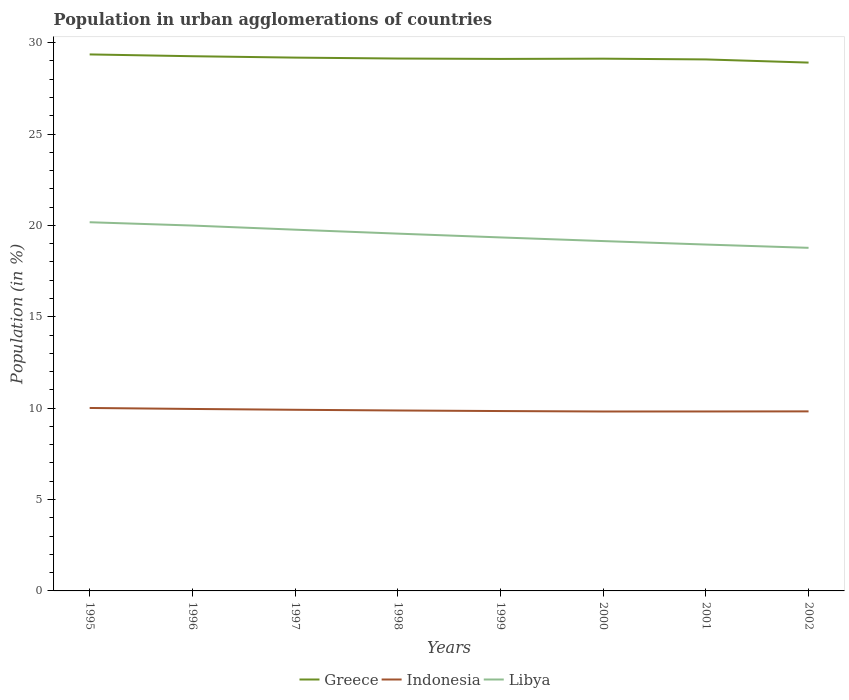How many different coloured lines are there?
Give a very brief answer. 3. Does the line corresponding to Greece intersect with the line corresponding to Indonesia?
Give a very brief answer. No. Is the number of lines equal to the number of legend labels?
Give a very brief answer. Yes. Across all years, what is the maximum percentage of population in urban agglomerations in Greece?
Your response must be concise. 28.91. In which year was the percentage of population in urban agglomerations in Indonesia maximum?
Provide a short and direct response. 2000. What is the total percentage of population in urban agglomerations in Indonesia in the graph?
Provide a succinct answer. 0.04. What is the difference between the highest and the second highest percentage of population in urban agglomerations in Indonesia?
Keep it short and to the point. 0.19. What is the difference between the highest and the lowest percentage of population in urban agglomerations in Indonesia?
Make the answer very short. 3. Is the percentage of population in urban agglomerations in Greece strictly greater than the percentage of population in urban agglomerations in Libya over the years?
Your answer should be compact. No. How many years are there in the graph?
Provide a short and direct response. 8. What is the difference between two consecutive major ticks on the Y-axis?
Give a very brief answer. 5. Are the values on the major ticks of Y-axis written in scientific E-notation?
Provide a short and direct response. No. What is the title of the graph?
Offer a terse response. Population in urban agglomerations of countries. What is the Population (in %) of Greece in 1995?
Provide a succinct answer. 29.35. What is the Population (in %) of Indonesia in 1995?
Ensure brevity in your answer.  10.01. What is the Population (in %) in Libya in 1995?
Make the answer very short. 20.17. What is the Population (in %) in Greece in 1996?
Provide a succinct answer. 29.26. What is the Population (in %) of Indonesia in 1996?
Offer a very short reply. 9.96. What is the Population (in %) in Libya in 1996?
Your answer should be very brief. 19.99. What is the Population (in %) of Greece in 1997?
Provide a short and direct response. 29.18. What is the Population (in %) in Indonesia in 1997?
Offer a terse response. 9.91. What is the Population (in %) of Libya in 1997?
Offer a very short reply. 19.77. What is the Population (in %) of Greece in 1998?
Offer a terse response. 29.13. What is the Population (in %) of Indonesia in 1998?
Offer a terse response. 9.87. What is the Population (in %) of Libya in 1998?
Keep it short and to the point. 19.55. What is the Population (in %) in Greece in 1999?
Ensure brevity in your answer.  29.11. What is the Population (in %) of Indonesia in 1999?
Your response must be concise. 9.84. What is the Population (in %) in Libya in 1999?
Keep it short and to the point. 19.34. What is the Population (in %) of Greece in 2000?
Provide a succinct answer. 29.12. What is the Population (in %) of Indonesia in 2000?
Your answer should be compact. 9.82. What is the Population (in %) of Libya in 2000?
Provide a succinct answer. 19.14. What is the Population (in %) of Greece in 2001?
Provide a succinct answer. 29.08. What is the Population (in %) of Indonesia in 2001?
Your response must be concise. 9.82. What is the Population (in %) in Libya in 2001?
Offer a very short reply. 18.95. What is the Population (in %) of Greece in 2002?
Keep it short and to the point. 28.91. What is the Population (in %) of Indonesia in 2002?
Ensure brevity in your answer.  9.82. What is the Population (in %) of Libya in 2002?
Your answer should be compact. 18.77. Across all years, what is the maximum Population (in %) of Greece?
Provide a short and direct response. 29.35. Across all years, what is the maximum Population (in %) in Indonesia?
Give a very brief answer. 10.01. Across all years, what is the maximum Population (in %) of Libya?
Keep it short and to the point. 20.17. Across all years, what is the minimum Population (in %) of Greece?
Keep it short and to the point. 28.91. Across all years, what is the minimum Population (in %) in Indonesia?
Keep it short and to the point. 9.82. Across all years, what is the minimum Population (in %) of Libya?
Offer a terse response. 18.77. What is the total Population (in %) in Greece in the graph?
Offer a terse response. 233.14. What is the total Population (in %) of Indonesia in the graph?
Make the answer very short. 79.05. What is the total Population (in %) in Libya in the graph?
Your response must be concise. 155.69. What is the difference between the Population (in %) of Greece in 1995 and that in 1996?
Give a very brief answer. 0.1. What is the difference between the Population (in %) of Indonesia in 1995 and that in 1996?
Your answer should be very brief. 0.05. What is the difference between the Population (in %) of Libya in 1995 and that in 1996?
Offer a terse response. 0.18. What is the difference between the Population (in %) in Greece in 1995 and that in 1997?
Offer a very short reply. 0.17. What is the difference between the Population (in %) in Indonesia in 1995 and that in 1997?
Ensure brevity in your answer.  0.1. What is the difference between the Population (in %) of Libya in 1995 and that in 1997?
Make the answer very short. 0.41. What is the difference between the Population (in %) in Greece in 1995 and that in 1998?
Provide a short and direct response. 0.22. What is the difference between the Population (in %) of Indonesia in 1995 and that in 1998?
Offer a terse response. 0.14. What is the difference between the Population (in %) of Libya in 1995 and that in 1998?
Offer a very short reply. 0.62. What is the difference between the Population (in %) in Greece in 1995 and that in 1999?
Give a very brief answer. 0.25. What is the difference between the Population (in %) of Indonesia in 1995 and that in 1999?
Keep it short and to the point. 0.17. What is the difference between the Population (in %) of Libya in 1995 and that in 1999?
Offer a terse response. 0.83. What is the difference between the Population (in %) in Greece in 1995 and that in 2000?
Provide a short and direct response. 0.23. What is the difference between the Population (in %) of Indonesia in 1995 and that in 2000?
Your response must be concise. 0.19. What is the difference between the Population (in %) in Libya in 1995 and that in 2000?
Provide a short and direct response. 1.03. What is the difference between the Population (in %) of Greece in 1995 and that in 2001?
Offer a terse response. 0.27. What is the difference between the Population (in %) of Indonesia in 1995 and that in 2001?
Make the answer very short. 0.19. What is the difference between the Population (in %) of Libya in 1995 and that in 2001?
Provide a short and direct response. 1.22. What is the difference between the Population (in %) of Greece in 1995 and that in 2002?
Ensure brevity in your answer.  0.45. What is the difference between the Population (in %) of Indonesia in 1995 and that in 2002?
Provide a short and direct response. 0.19. What is the difference between the Population (in %) of Libya in 1995 and that in 2002?
Your response must be concise. 1.4. What is the difference between the Population (in %) in Greece in 1996 and that in 1997?
Keep it short and to the point. 0.08. What is the difference between the Population (in %) of Indonesia in 1996 and that in 1997?
Provide a short and direct response. 0.05. What is the difference between the Population (in %) in Libya in 1996 and that in 1997?
Your answer should be very brief. 0.23. What is the difference between the Population (in %) of Greece in 1996 and that in 1998?
Ensure brevity in your answer.  0.13. What is the difference between the Population (in %) in Indonesia in 1996 and that in 1998?
Give a very brief answer. 0.08. What is the difference between the Population (in %) in Libya in 1996 and that in 1998?
Ensure brevity in your answer.  0.44. What is the difference between the Population (in %) of Greece in 1996 and that in 1999?
Offer a very short reply. 0.15. What is the difference between the Population (in %) in Indonesia in 1996 and that in 1999?
Give a very brief answer. 0.12. What is the difference between the Population (in %) in Libya in 1996 and that in 1999?
Offer a terse response. 0.65. What is the difference between the Population (in %) in Greece in 1996 and that in 2000?
Keep it short and to the point. 0.13. What is the difference between the Population (in %) of Indonesia in 1996 and that in 2000?
Ensure brevity in your answer.  0.14. What is the difference between the Population (in %) of Libya in 1996 and that in 2000?
Your response must be concise. 0.85. What is the difference between the Population (in %) in Greece in 1996 and that in 2001?
Provide a succinct answer. 0.18. What is the difference between the Population (in %) in Indonesia in 1996 and that in 2001?
Your response must be concise. 0.14. What is the difference between the Population (in %) of Libya in 1996 and that in 2001?
Your response must be concise. 1.04. What is the difference between the Population (in %) of Greece in 1996 and that in 2002?
Make the answer very short. 0.35. What is the difference between the Population (in %) of Indonesia in 1996 and that in 2002?
Provide a short and direct response. 0.13. What is the difference between the Population (in %) in Libya in 1996 and that in 2002?
Ensure brevity in your answer.  1.22. What is the difference between the Population (in %) in Greece in 1997 and that in 1998?
Give a very brief answer. 0.05. What is the difference between the Population (in %) of Indonesia in 1997 and that in 1998?
Your answer should be compact. 0.04. What is the difference between the Population (in %) of Libya in 1997 and that in 1998?
Give a very brief answer. 0.22. What is the difference between the Population (in %) in Greece in 1997 and that in 1999?
Keep it short and to the point. 0.07. What is the difference between the Population (in %) of Indonesia in 1997 and that in 1999?
Make the answer very short. 0.07. What is the difference between the Population (in %) in Libya in 1997 and that in 1999?
Provide a short and direct response. 0.42. What is the difference between the Population (in %) of Greece in 1997 and that in 2000?
Ensure brevity in your answer.  0.06. What is the difference between the Population (in %) in Indonesia in 1997 and that in 2000?
Make the answer very short. 0.09. What is the difference between the Population (in %) in Libya in 1997 and that in 2000?
Make the answer very short. 0.62. What is the difference between the Population (in %) of Greece in 1997 and that in 2001?
Offer a terse response. 0.1. What is the difference between the Population (in %) of Indonesia in 1997 and that in 2001?
Make the answer very short. 0.09. What is the difference between the Population (in %) of Libya in 1997 and that in 2001?
Your answer should be very brief. 0.81. What is the difference between the Population (in %) in Greece in 1997 and that in 2002?
Your response must be concise. 0.27. What is the difference between the Population (in %) of Indonesia in 1997 and that in 2002?
Your answer should be very brief. 0.09. What is the difference between the Population (in %) in Libya in 1997 and that in 2002?
Give a very brief answer. 0.99. What is the difference between the Population (in %) of Greece in 1998 and that in 1999?
Your response must be concise. 0.02. What is the difference between the Population (in %) of Indonesia in 1998 and that in 1999?
Give a very brief answer. 0.03. What is the difference between the Population (in %) of Libya in 1998 and that in 1999?
Your answer should be very brief. 0.21. What is the difference between the Population (in %) in Greece in 1998 and that in 2000?
Provide a short and direct response. 0.01. What is the difference between the Population (in %) of Indonesia in 1998 and that in 2000?
Your response must be concise. 0.06. What is the difference between the Population (in %) of Libya in 1998 and that in 2000?
Offer a terse response. 0.41. What is the difference between the Population (in %) of Greece in 1998 and that in 2001?
Provide a short and direct response. 0.05. What is the difference between the Population (in %) in Indonesia in 1998 and that in 2001?
Offer a terse response. 0.05. What is the difference between the Population (in %) in Libya in 1998 and that in 2001?
Provide a succinct answer. 0.6. What is the difference between the Population (in %) of Greece in 1998 and that in 2002?
Your response must be concise. 0.22. What is the difference between the Population (in %) of Indonesia in 1998 and that in 2002?
Give a very brief answer. 0.05. What is the difference between the Population (in %) of Libya in 1998 and that in 2002?
Provide a short and direct response. 0.78. What is the difference between the Population (in %) of Greece in 1999 and that in 2000?
Your response must be concise. -0.01. What is the difference between the Population (in %) in Indonesia in 1999 and that in 2000?
Offer a very short reply. 0.02. What is the difference between the Population (in %) of Libya in 1999 and that in 2000?
Offer a terse response. 0.2. What is the difference between the Population (in %) in Greece in 1999 and that in 2001?
Your answer should be compact. 0.03. What is the difference between the Population (in %) of Indonesia in 1999 and that in 2001?
Your response must be concise. 0.02. What is the difference between the Population (in %) of Libya in 1999 and that in 2001?
Offer a terse response. 0.39. What is the difference between the Population (in %) in Greece in 1999 and that in 2002?
Your answer should be very brief. 0.2. What is the difference between the Population (in %) in Indonesia in 1999 and that in 2002?
Provide a succinct answer. 0.02. What is the difference between the Population (in %) of Libya in 1999 and that in 2002?
Your answer should be compact. 0.57. What is the difference between the Population (in %) of Greece in 2000 and that in 2001?
Ensure brevity in your answer.  0.04. What is the difference between the Population (in %) of Indonesia in 2000 and that in 2001?
Keep it short and to the point. -0. What is the difference between the Population (in %) in Libya in 2000 and that in 2001?
Offer a very short reply. 0.19. What is the difference between the Population (in %) in Greece in 2000 and that in 2002?
Provide a succinct answer. 0.21. What is the difference between the Population (in %) in Indonesia in 2000 and that in 2002?
Offer a very short reply. -0.01. What is the difference between the Population (in %) of Libya in 2000 and that in 2002?
Your answer should be very brief. 0.37. What is the difference between the Population (in %) in Greece in 2001 and that in 2002?
Offer a terse response. 0.17. What is the difference between the Population (in %) in Indonesia in 2001 and that in 2002?
Offer a very short reply. -0. What is the difference between the Population (in %) of Libya in 2001 and that in 2002?
Offer a very short reply. 0.18. What is the difference between the Population (in %) in Greece in 1995 and the Population (in %) in Indonesia in 1996?
Provide a short and direct response. 19.4. What is the difference between the Population (in %) in Greece in 1995 and the Population (in %) in Libya in 1996?
Provide a short and direct response. 9.36. What is the difference between the Population (in %) of Indonesia in 1995 and the Population (in %) of Libya in 1996?
Your response must be concise. -9.98. What is the difference between the Population (in %) in Greece in 1995 and the Population (in %) in Indonesia in 1997?
Your response must be concise. 19.44. What is the difference between the Population (in %) in Greece in 1995 and the Population (in %) in Libya in 1997?
Keep it short and to the point. 9.59. What is the difference between the Population (in %) of Indonesia in 1995 and the Population (in %) of Libya in 1997?
Your response must be concise. -9.76. What is the difference between the Population (in %) of Greece in 1995 and the Population (in %) of Indonesia in 1998?
Provide a succinct answer. 19.48. What is the difference between the Population (in %) of Greece in 1995 and the Population (in %) of Libya in 1998?
Your response must be concise. 9.8. What is the difference between the Population (in %) of Indonesia in 1995 and the Population (in %) of Libya in 1998?
Your response must be concise. -9.54. What is the difference between the Population (in %) in Greece in 1995 and the Population (in %) in Indonesia in 1999?
Your answer should be compact. 19.51. What is the difference between the Population (in %) in Greece in 1995 and the Population (in %) in Libya in 1999?
Give a very brief answer. 10.01. What is the difference between the Population (in %) of Indonesia in 1995 and the Population (in %) of Libya in 1999?
Offer a terse response. -9.33. What is the difference between the Population (in %) in Greece in 1995 and the Population (in %) in Indonesia in 2000?
Keep it short and to the point. 19.54. What is the difference between the Population (in %) in Greece in 1995 and the Population (in %) in Libya in 2000?
Offer a very short reply. 10.21. What is the difference between the Population (in %) in Indonesia in 1995 and the Population (in %) in Libya in 2000?
Provide a short and direct response. -9.13. What is the difference between the Population (in %) in Greece in 1995 and the Population (in %) in Indonesia in 2001?
Provide a short and direct response. 19.54. What is the difference between the Population (in %) of Greece in 1995 and the Population (in %) of Libya in 2001?
Ensure brevity in your answer.  10.4. What is the difference between the Population (in %) in Indonesia in 1995 and the Population (in %) in Libya in 2001?
Offer a terse response. -8.94. What is the difference between the Population (in %) in Greece in 1995 and the Population (in %) in Indonesia in 2002?
Your answer should be very brief. 19.53. What is the difference between the Population (in %) in Greece in 1995 and the Population (in %) in Libya in 2002?
Your answer should be very brief. 10.58. What is the difference between the Population (in %) of Indonesia in 1995 and the Population (in %) of Libya in 2002?
Your answer should be very brief. -8.76. What is the difference between the Population (in %) of Greece in 1996 and the Population (in %) of Indonesia in 1997?
Your response must be concise. 19.35. What is the difference between the Population (in %) in Greece in 1996 and the Population (in %) in Libya in 1997?
Provide a succinct answer. 9.49. What is the difference between the Population (in %) of Indonesia in 1996 and the Population (in %) of Libya in 1997?
Your answer should be compact. -9.81. What is the difference between the Population (in %) of Greece in 1996 and the Population (in %) of Indonesia in 1998?
Offer a terse response. 19.38. What is the difference between the Population (in %) in Greece in 1996 and the Population (in %) in Libya in 1998?
Keep it short and to the point. 9.71. What is the difference between the Population (in %) in Indonesia in 1996 and the Population (in %) in Libya in 1998?
Offer a very short reply. -9.59. What is the difference between the Population (in %) in Greece in 1996 and the Population (in %) in Indonesia in 1999?
Ensure brevity in your answer.  19.41. What is the difference between the Population (in %) in Greece in 1996 and the Population (in %) in Libya in 1999?
Your answer should be very brief. 9.91. What is the difference between the Population (in %) of Indonesia in 1996 and the Population (in %) of Libya in 1999?
Offer a very short reply. -9.39. What is the difference between the Population (in %) in Greece in 1996 and the Population (in %) in Indonesia in 2000?
Provide a short and direct response. 19.44. What is the difference between the Population (in %) in Greece in 1996 and the Population (in %) in Libya in 2000?
Offer a terse response. 10.11. What is the difference between the Population (in %) of Indonesia in 1996 and the Population (in %) of Libya in 2000?
Offer a very short reply. -9.19. What is the difference between the Population (in %) in Greece in 1996 and the Population (in %) in Indonesia in 2001?
Provide a succinct answer. 19.44. What is the difference between the Population (in %) of Greece in 1996 and the Population (in %) of Libya in 2001?
Give a very brief answer. 10.3. What is the difference between the Population (in %) in Indonesia in 1996 and the Population (in %) in Libya in 2001?
Keep it short and to the point. -9. What is the difference between the Population (in %) in Greece in 1996 and the Population (in %) in Indonesia in 2002?
Your answer should be compact. 19.43. What is the difference between the Population (in %) of Greece in 1996 and the Population (in %) of Libya in 2002?
Your response must be concise. 10.48. What is the difference between the Population (in %) in Indonesia in 1996 and the Population (in %) in Libya in 2002?
Your answer should be very brief. -8.82. What is the difference between the Population (in %) of Greece in 1997 and the Population (in %) of Indonesia in 1998?
Make the answer very short. 19.31. What is the difference between the Population (in %) of Greece in 1997 and the Population (in %) of Libya in 1998?
Your response must be concise. 9.63. What is the difference between the Population (in %) in Indonesia in 1997 and the Population (in %) in Libya in 1998?
Offer a terse response. -9.64. What is the difference between the Population (in %) in Greece in 1997 and the Population (in %) in Indonesia in 1999?
Your answer should be compact. 19.34. What is the difference between the Population (in %) in Greece in 1997 and the Population (in %) in Libya in 1999?
Your answer should be compact. 9.84. What is the difference between the Population (in %) in Indonesia in 1997 and the Population (in %) in Libya in 1999?
Your response must be concise. -9.43. What is the difference between the Population (in %) in Greece in 1997 and the Population (in %) in Indonesia in 2000?
Your response must be concise. 19.36. What is the difference between the Population (in %) in Greece in 1997 and the Population (in %) in Libya in 2000?
Your answer should be compact. 10.04. What is the difference between the Population (in %) in Indonesia in 1997 and the Population (in %) in Libya in 2000?
Provide a succinct answer. -9.23. What is the difference between the Population (in %) of Greece in 1997 and the Population (in %) of Indonesia in 2001?
Your answer should be very brief. 19.36. What is the difference between the Population (in %) in Greece in 1997 and the Population (in %) in Libya in 2001?
Keep it short and to the point. 10.23. What is the difference between the Population (in %) in Indonesia in 1997 and the Population (in %) in Libya in 2001?
Your answer should be very brief. -9.04. What is the difference between the Population (in %) of Greece in 1997 and the Population (in %) of Indonesia in 2002?
Your answer should be compact. 19.36. What is the difference between the Population (in %) of Greece in 1997 and the Population (in %) of Libya in 2002?
Give a very brief answer. 10.41. What is the difference between the Population (in %) in Indonesia in 1997 and the Population (in %) in Libya in 2002?
Offer a very short reply. -8.86. What is the difference between the Population (in %) in Greece in 1998 and the Population (in %) in Indonesia in 1999?
Your answer should be compact. 19.29. What is the difference between the Population (in %) of Greece in 1998 and the Population (in %) of Libya in 1999?
Your answer should be very brief. 9.79. What is the difference between the Population (in %) in Indonesia in 1998 and the Population (in %) in Libya in 1999?
Ensure brevity in your answer.  -9.47. What is the difference between the Population (in %) of Greece in 1998 and the Population (in %) of Indonesia in 2000?
Provide a succinct answer. 19.31. What is the difference between the Population (in %) of Greece in 1998 and the Population (in %) of Libya in 2000?
Give a very brief answer. 9.99. What is the difference between the Population (in %) in Indonesia in 1998 and the Population (in %) in Libya in 2000?
Your response must be concise. -9.27. What is the difference between the Population (in %) of Greece in 1998 and the Population (in %) of Indonesia in 2001?
Provide a short and direct response. 19.31. What is the difference between the Population (in %) in Greece in 1998 and the Population (in %) in Libya in 2001?
Your answer should be very brief. 10.18. What is the difference between the Population (in %) in Indonesia in 1998 and the Population (in %) in Libya in 2001?
Your response must be concise. -9.08. What is the difference between the Population (in %) in Greece in 1998 and the Population (in %) in Indonesia in 2002?
Your answer should be compact. 19.31. What is the difference between the Population (in %) in Greece in 1998 and the Population (in %) in Libya in 2002?
Provide a short and direct response. 10.36. What is the difference between the Population (in %) of Indonesia in 1998 and the Population (in %) of Libya in 2002?
Offer a very short reply. -8.9. What is the difference between the Population (in %) in Greece in 1999 and the Population (in %) in Indonesia in 2000?
Provide a short and direct response. 19.29. What is the difference between the Population (in %) of Greece in 1999 and the Population (in %) of Libya in 2000?
Give a very brief answer. 9.97. What is the difference between the Population (in %) in Indonesia in 1999 and the Population (in %) in Libya in 2000?
Keep it short and to the point. -9.3. What is the difference between the Population (in %) in Greece in 1999 and the Population (in %) in Indonesia in 2001?
Give a very brief answer. 19.29. What is the difference between the Population (in %) in Greece in 1999 and the Population (in %) in Libya in 2001?
Your answer should be very brief. 10.16. What is the difference between the Population (in %) in Indonesia in 1999 and the Population (in %) in Libya in 2001?
Your answer should be very brief. -9.11. What is the difference between the Population (in %) in Greece in 1999 and the Population (in %) in Indonesia in 2002?
Keep it short and to the point. 19.29. What is the difference between the Population (in %) in Greece in 1999 and the Population (in %) in Libya in 2002?
Keep it short and to the point. 10.34. What is the difference between the Population (in %) of Indonesia in 1999 and the Population (in %) of Libya in 2002?
Your answer should be very brief. -8.93. What is the difference between the Population (in %) of Greece in 2000 and the Population (in %) of Indonesia in 2001?
Your response must be concise. 19.3. What is the difference between the Population (in %) in Greece in 2000 and the Population (in %) in Libya in 2001?
Your response must be concise. 10.17. What is the difference between the Population (in %) in Indonesia in 2000 and the Population (in %) in Libya in 2001?
Make the answer very short. -9.13. What is the difference between the Population (in %) of Greece in 2000 and the Population (in %) of Indonesia in 2002?
Offer a terse response. 19.3. What is the difference between the Population (in %) of Greece in 2000 and the Population (in %) of Libya in 2002?
Keep it short and to the point. 10.35. What is the difference between the Population (in %) in Indonesia in 2000 and the Population (in %) in Libya in 2002?
Your response must be concise. -8.96. What is the difference between the Population (in %) in Greece in 2001 and the Population (in %) in Indonesia in 2002?
Your answer should be very brief. 19.26. What is the difference between the Population (in %) in Greece in 2001 and the Population (in %) in Libya in 2002?
Offer a terse response. 10.31. What is the difference between the Population (in %) of Indonesia in 2001 and the Population (in %) of Libya in 2002?
Ensure brevity in your answer.  -8.95. What is the average Population (in %) of Greece per year?
Give a very brief answer. 29.14. What is the average Population (in %) in Indonesia per year?
Your answer should be very brief. 9.88. What is the average Population (in %) of Libya per year?
Offer a terse response. 19.46. In the year 1995, what is the difference between the Population (in %) in Greece and Population (in %) in Indonesia?
Your response must be concise. 19.34. In the year 1995, what is the difference between the Population (in %) of Greece and Population (in %) of Libya?
Ensure brevity in your answer.  9.18. In the year 1995, what is the difference between the Population (in %) in Indonesia and Population (in %) in Libya?
Provide a short and direct response. -10.16. In the year 1996, what is the difference between the Population (in %) of Greece and Population (in %) of Indonesia?
Your answer should be very brief. 19.3. In the year 1996, what is the difference between the Population (in %) in Greece and Population (in %) in Libya?
Provide a succinct answer. 9.27. In the year 1996, what is the difference between the Population (in %) in Indonesia and Population (in %) in Libya?
Offer a very short reply. -10.03. In the year 1997, what is the difference between the Population (in %) of Greece and Population (in %) of Indonesia?
Your response must be concise. 19.27. In the year 1997, what is the difference between the Population (in %) of Greece and Population (in %) of Libya?
Offer a terse response. 9.41. In the year 1997, what is the difference between the Population (in %) of Indonesia and Population (in %) of Libya?
Provide a short and direct response. -9.85. In the year 1998, what is the difference between the Population (in %) in Greece and Population (in %) in Indonesia?
Your answer should be very brief. 19.26. In the year 1998, what is the difference between the Population (in %) of Greece and Population (in %) of Libya?
Keep it short and to the point. 9.58. In the year 1998, what is the difference between the Population (in %) in Indonesia and Population (in %) in Libya?
Make the answer very short. -9.68. In the year 1999, what is the difference between the Population (in %) of Greece and Population (in %) of Indonesia?
Offer a very short reply. 19.27. In the year 1999, what is the difference between the Population (in %) of Greece and Population (in %) of Libya?
Provide a short and direct response. 9.77. In the year 1999, what is the difference between the Population (in %) of Indonesia and Population (in %) of Libya?
Give a very brief answer. -9.5. In the year 2000, what is the difference between the Population (in %) of Greece and Population (in %) of Indonesia?
Your answer should be compact. 19.3. In the year 2000, what is the difference between the Population (in %) of Greece and Population (in %) of Libya?
Keep it short and to the point. 9.98. In the year 2000, what is the difference between the Population (in %) of Indonesia and Population (in %) of Libya?
Keep it short and to the point. -9.32. In the year 2001, what is the difference between the Population (in %) in Greece and Population (in %) in Indonesia?
Offer a very short reply. 19.26. In the year 2001, what is the difference between the Population (in %) in Greece and Population (in %) in Libya?
Give a very brief answer. 10.13. In the year 2001, what is the difference between the Population (in %) in Indonesia and Population (in %) in Libya?
Keep it short and to the point. -9.13. In the year 2002, what is the difference between the Population (in %) of Greece and Population (in %) of Indonesia?
Provide a short and direct response. 19.08. In the year 2002, what is the difference between the Population (in %) of Greece and Population (in %) of Libya?
Keep it short and to the point. 10.13. In the year 2002, what is the difference between the Population (in %) of Indonesia and Population (in %) of Libya?
Provide a succinct answer. -8.95. What is the ratio of the Population (in %) in Indonesia in 1995 to that in 1996?
Your answer should be compact. 1.01. What is the ratio of the Population (in %) in Libya in 1995 to that in 1996?
Your response must be concise. 1.01. What is the ratio of the Population (in %) in Indonesia in 1995 to that in 1997?
Your response must be concise. 1.01. What is the ratio of the Population (in %) in Libya in 1995 to that in 1997?
Your answer should be very brief. 1.02. What is the ratio of the Population (in %) in Greece in 1995 to that in 1998?
Give a very brief answer. 1.01. What is the ratio of the Population (in %) in Indonesia in 1995 to that in 1998?
Keep it short and to the point. 1.01. What is the ratio of the Population (in %) of Libya in 1995 to that in 1998?
Your answer should be very brief. 1.03. What is the ratio of the Population (in %) in Greece in 1995 to that in 1999?
Ensure brevity in your answer.  1.01. What is the ratio of the Population (in %) of Indonesia in 1995 to that in 1999?
Provide a short and direct response. 1.02. What is the ratio of the Population (in %) of Libya in 1995 to that in 1999?
Provide a short and direct response. 1.04. What is the ratio of the Population (in %) in Indonesia in 1995 to that in 2000?
Provide a succinct answer. 1.02. What is the ratio of the Population (in %) of Libya in 1995 to that in 2000?
Your answer should be very brief. 1.05. What is the ratio of the Population (in %) in Greece in 1995 to that in 2001?
Keep it short and to the point. 1.01. What is the ratio of the Population (in %) in Indonesia in 1995 to that in 2001?
Give a very brief answer. 1.02. What is the ratio of the Population (in %) of Libya in 1995 to that in 2001?
Provide a short and direct response. 1.06. What is the ratio of the Population (in %) of Greece in 1995 to that in 2002?
Offer a terse response. 1.02. What is the ratio of the Population (in %) in Indonesia in 1995 to that in 2002?
Give a very brief answer. 1.02. What is the ratio of the Population (in %) in Libya in 1995 to that in 2002?
Provide a short and direct response. 1.07. What is the ratio of the Population (in %) in Greece in 1996 to that in 1997?
Your answer should be very brief. 1. What is the ratio of the Population (in %) of Indonesia in 1996 to that in 1997?
Ensure brevity in your answer.  1. What is the ratio of the Population (in %) of Libya in 1996 to that in 1997?
Keep it short and to the point. 1.01. What is the ratio of the Population (in %) in Greece in 1996 to that in 1998?
Offer a very short reply. 1. What is the ratio of the Population (in %) of Indonesia in 1996 to that in 1998?
Your answer should be compact. 1.01. What is the ratio of the Population (in %) in Libya in 1996 to that in 1998?
Offer a terse response. 1.02. What is the ratio of the Population (in %) in Greece in 1996 to that in 1999?
Keep it short and to the point. 1.01. What is the ratio of the Population (in %) of Indonesia in 1996 to that in 1999?
Ensure brevity in your answer.  1.01. What is the ratio of the Population (in %) of Libya in 1996 to that in 1999?
Provide a short and direct response. 1.03. What is the ratio of the Population (in %) of Greece in 1996 to that in 2000?
Your answer should be very brief. 1. What is the ratio of the Population (in %) of Indonesia in 1996 to that in 2000?
Keep it short and to the point. 1.01. What is the ratio of the Population (in %) of Libya in 1996 to that in 2000?
Ensure brevity in your answer.  1.04. What is the ratio of the Population (in %) of Indonesia in 1996 to that in 2001?
Make the answer very short. 1.01. What is the ratio of the Population (in %) of Libya in 1996 to that in 2001?
Offer a very short reply. 1.05. What is the ratio of the Population (in %) of Greece in 1996 to that in 2002?
Your answer should be compact. 1.01. What is the ratio of the Population (in %) in Indonesia in 1996 to that in 2002?
Ensure brevity in your answer.  1.01. What is the ratio of the Population (in %) in Libya in 1996 to that in 2002?
Offer a terse response. 1.06. What is the ratio of the Population (in %) in Greece in 1997 to that in 1998?
Offer a terse response. 1. What is the ratio of the Population (in %) in Libya in 1997 to that in 1998?
Provide a succinct answer. 1.01. What is the ratio of the Population (in %) in Libya in 1997 to that in 1999?
Provide a short and direct response. 1.02. What is the ratio of the Population (in %) of Greece in 1997 to that in 2000?
Your answer should be very brief. 1. What is the ratio of the Population (in %) of Indonesia in 1997 to that in 2000?
Give a very brief answer. 1.01. What is the ratio of the Population (in %) in Libya in 1997 to that in 2000?
Ensure brevity in your answer.  1.03. What is the ratio of the Population (in %) in Indonesia in 1997 to that in 2001?
Make the answer very short. 1.01. What is the ratio of the Population (in %) in Libya in 1997 to that in 2001?
Offer a very short reply. 1.04. What is the ratio of the Population (in %) of Greece in 1997 to that in 2002?
Keep it short and to the point. 1.01. What is the ratio of the Population (in %) in Indonesia in 1997 to that in 2002?
Provide a short and direct response. 1.01. What is the ratio of the Population (in %) in Libya in 1997 to that in 2002?
Keep it short and to the point. 1.05. What is the ratio of the Population (in %) of Libya in 1998 to that in 1999?
Your answer should be compact. 1.01. What is the ratio of the Population (in %) of Greece in 1998 to that in 2000?
Your answer should be compact. 1. What is the ratio of the Population (in %) in Indonesia in 1998 to that in 2000?
Offer a very short reply. 1.01. What is the ratio of the Population (in %) in Libya in 1998 to that in 2000?
Provide a short and direct response. 1.02. What is the ratio of the Population (in %) in Indonesia in 1998 to that in 2001?
Ensure brevity in your answer.  1.01. What is the ratio of the Population (in %) of Libya in 1998 to that in 2001?
Offer a terse response. 1.03. What is the ratio of the Population (in %) in Greece in 1998 to that in 2002?
Offer a terse response. 1.01. What is the ratio of the Population (in %) in Indonesia in 1998 to that in 2002?
Offer a terse response. 1. What is the ratio of the Population (in %) in Libya in 1998 to that in 2002?
Keep it short and to the point. 1.04. What is the ratio of the Population (in %) in Greece in 1999 to that in 2000?
Give a very brief answer. 1. What is the ratio of the Population (in %) in Indonesia in 1999 to that in 2000?
Keep it short and to the point. 1. What is the ratio of the Population (in %) in Libya in 1999 to that in 2000?
Your answer should be very brief. 1.01. What is the ratio of the Population (in %) in Libya in 1999 to that in 2001?
Keep it short and to the point. 1.02. What is the ratio of the Population (in %) in Libya in 1999 to that in 2002?
Offer a terse response. 1.03. What is the ratio of the Population (in %) in Indonesia in 2000 to that in 2001?
Offer a terse response. 1. What is the ratio of the Population (in %) of Greece in 2000 to that in 2002?
Your answer should be compact. 1.01. What is the ratio of the Population (in %) of Indonesia in 2000 to that in 2002?
Your answer should be very brief. 1. What is the ratio of the Population (in %) of Libya in 2000 to that in 2002?
Keep it short and to the point. 1.02. What is the ratio of the Population (in %) of Libya in 2001 to that in 2002?
Ensure brevity in your answer.  1.01. What is the difference between the highest and the second highest Population (in %) in Greece?
Provide a short and direct response. 0.1. What is the difference between the highest and the second highest Population (in %) of Indonesia?
Make the answer very short. 0.05. What is the difference between the highest and the second highest Population (in %) in Libya?
Make the answer very short. 0.18. What is the difference between the highest and the lowest Population (in %) of Greece?
Offer a very short reply. 0.45. What is the difference between the highest and the lowest Population (in %) in Indonesia?
Your response must be concise. 0.19. What is the difference between the highest and the lowest Population (in %) of Libya?
Offer a terse response. 1.4. 